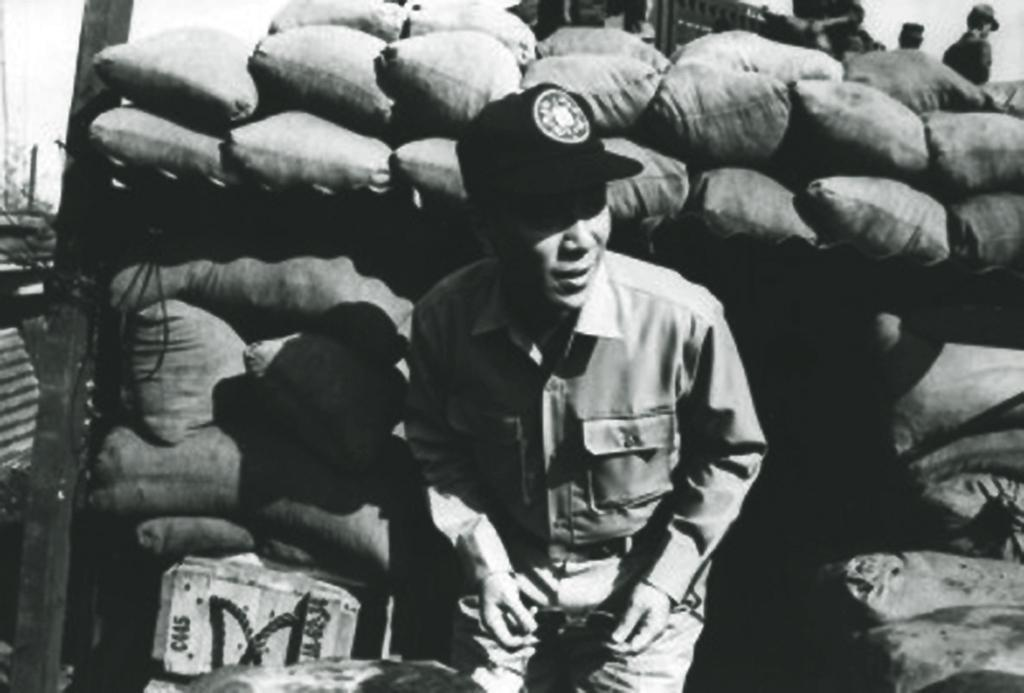Who is present in the image? There is a man in the image. What is the man wearing on his upper body? The man is wearing a shirt. What is the man wearing on his lower body? The man is wearing trousers. What is the man wearing on his head? The man is wearing a cap. What can be seen in the background of the image? There are gunny bags in the background of the image. What is the color scheme of the image? The image is in black and white color. What type of bean is being roasted in the image? There is no bean present in the image, and no roasting activity is depicted. 